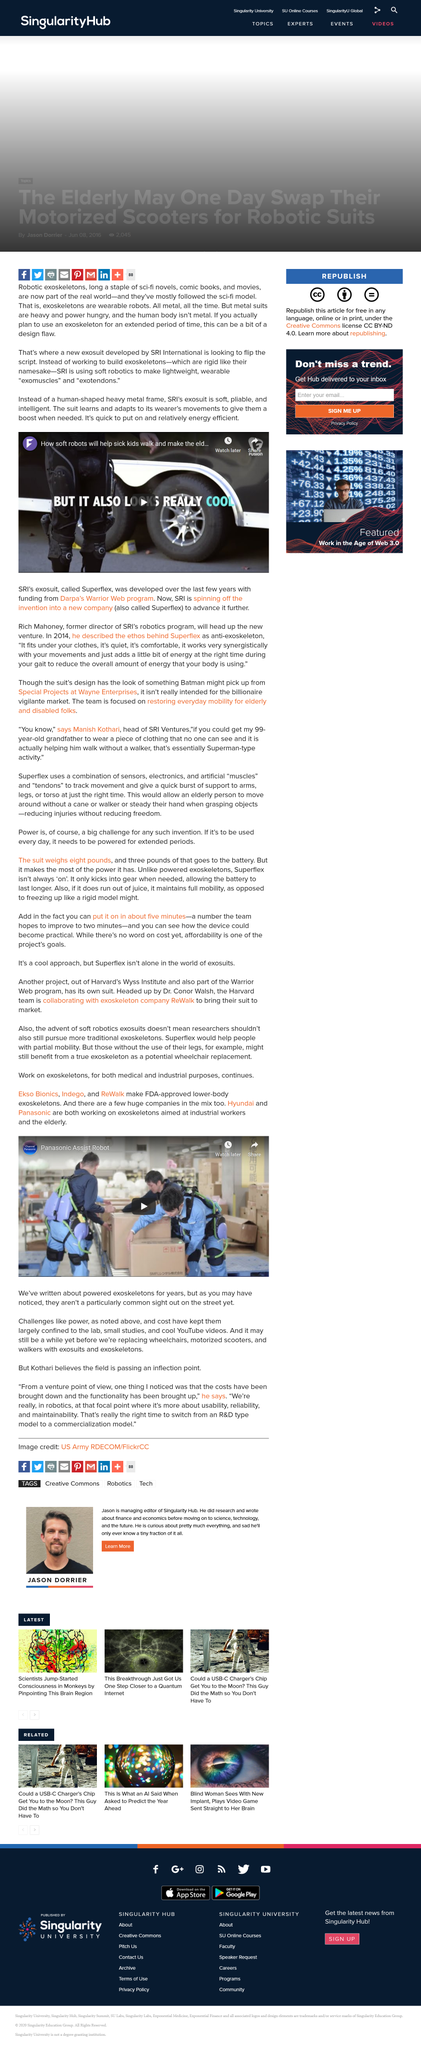Indicate a few pertinent items in this graphic. Exoskeletons, also known as exomuscles and exotendons, are soft, lightweight, and more wearable alternatives to traditional rigid exoskeletons. These exoskeletons provide support and assistance to the human body, allowing individuals to perform tasks that may be difficult or impossible without the added support. Exomuscles and exotendons are made of flexible materials that conform to the wearer's body, making them more comfortable and easier to wear for extended periods of time. These exoskeletons have a wide range of applications, including rehabilitation, assistive technology, and robotics. Ekso Bionics, Indego, and ReWalk make FDA approved, lower body, exoskeletons. Hyundai and Panasonic are collaborating to develop exoskeletons for both industrial workers and the elderly, in an effort to enhance their productivity and safety, respectively. Exoskeletons and exosuits have the potential to replace wheelchairs, motorized scooters, and walkers by providing a more dynamic and assistive option for individuals with mobility impairments. Exoskeletons are typically constructed using strong and durable materials such as metal, which allows them to withstand the demands of heavy lifting and other physically taxing tasks. 